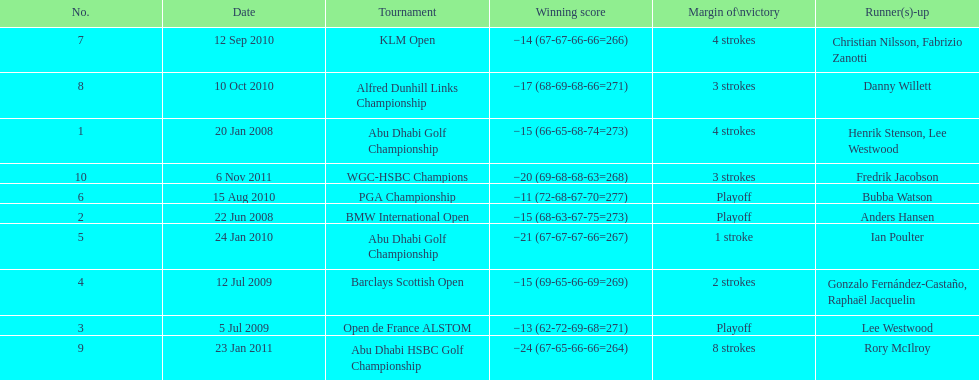How many winning scores were less than -14? 2. 